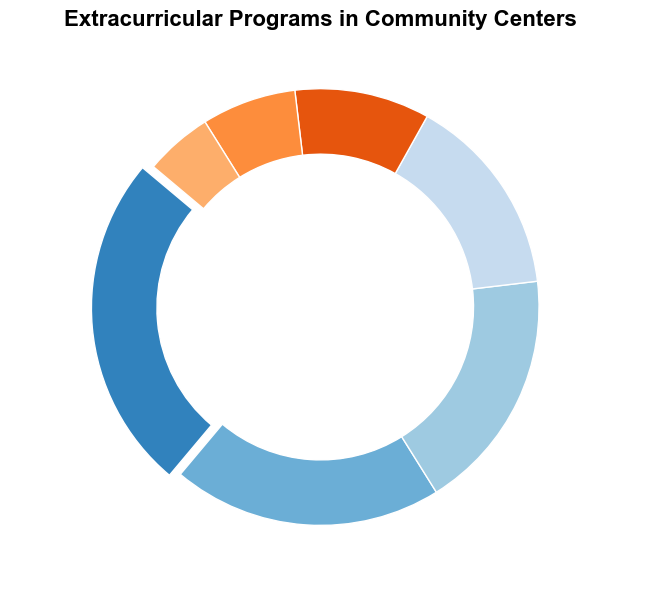What is the most common type of extracurricular program offered? The slice with the largest proportion in the pie chart represents the most common program type. The "Tutoring" segment has the highest percentage at 25%, which makes it the most common type of extracurricular program offered.
Answer: Tutoring Which program type has the smallest percentage, and what is that percentage? Look for the smallest slice in the pie chart, which corresponds to the program type with the smallest percentage. "Cooking Classes" has the smallest segment, indicating that it has the smallest percentage at 5%.
Answer: Cooking Classes, 5% Which is more common: Music Lessons or Computer Literacy programs? Compare the sizes of the "Music Lessons" and "Computer Literacy" slices in the pie chart. The "Music Lessons" segment is larger, indicating a higher percentage (15%) compared to "Computer Literacy" (7%).
Answer: Music Lessons What is the combined percentage of Arts and Crafts and Dance Classes programs? Sum the percentages of "Arts and Crafts" (18%) and "Dance Classes" (10%) from the pie chart. The combined percentage is 18% + 10%.
Answer: 28% By how many percentage points does Sports exceed Computer Literacy programs? Subtract the percentage of "Computer Literacy" (7%) from the percentage of "Sports" (20%). The difference is 20% - 7%.
Answer: 13 Which program types constitute more than one-third combined? Calculate one-third of the total pie (which is 100%). One-third of 100% is approximately 33.33%. Identify program types whose percentages sum up to more than 33.33%. Tutoring (25%) and Sports (20%) together exceed one-third, as their combined percentage is 45%.
Answer: Tutoring and Sports Describe the visual feature that makes the Tutoring segment stand out. The Tutoring slice is visually distinctive due to an "explode" effect that slightly separates it from the main pie, and it has the largest size.
Answer: Explode effect and largest size Which program type and percentage lies exactly between Dance Classes and Computer Literacy in terms of percentage? Find the program whose percentage is between "Dance Classes" (10%) and "Computer Literacy" (7%). "Dance Classes" at 10% is greater than "Computer Literacy" at 7%, and there are no program percentages between them.
Answer: No program lies between Dance Classes and Computer Literacy What is the total percentage of all extracurricular programs offered? The total of all segments in a pie chart is always 100% as it represents the whole. Summing up all portions gives 100%.
Answer: 100% 